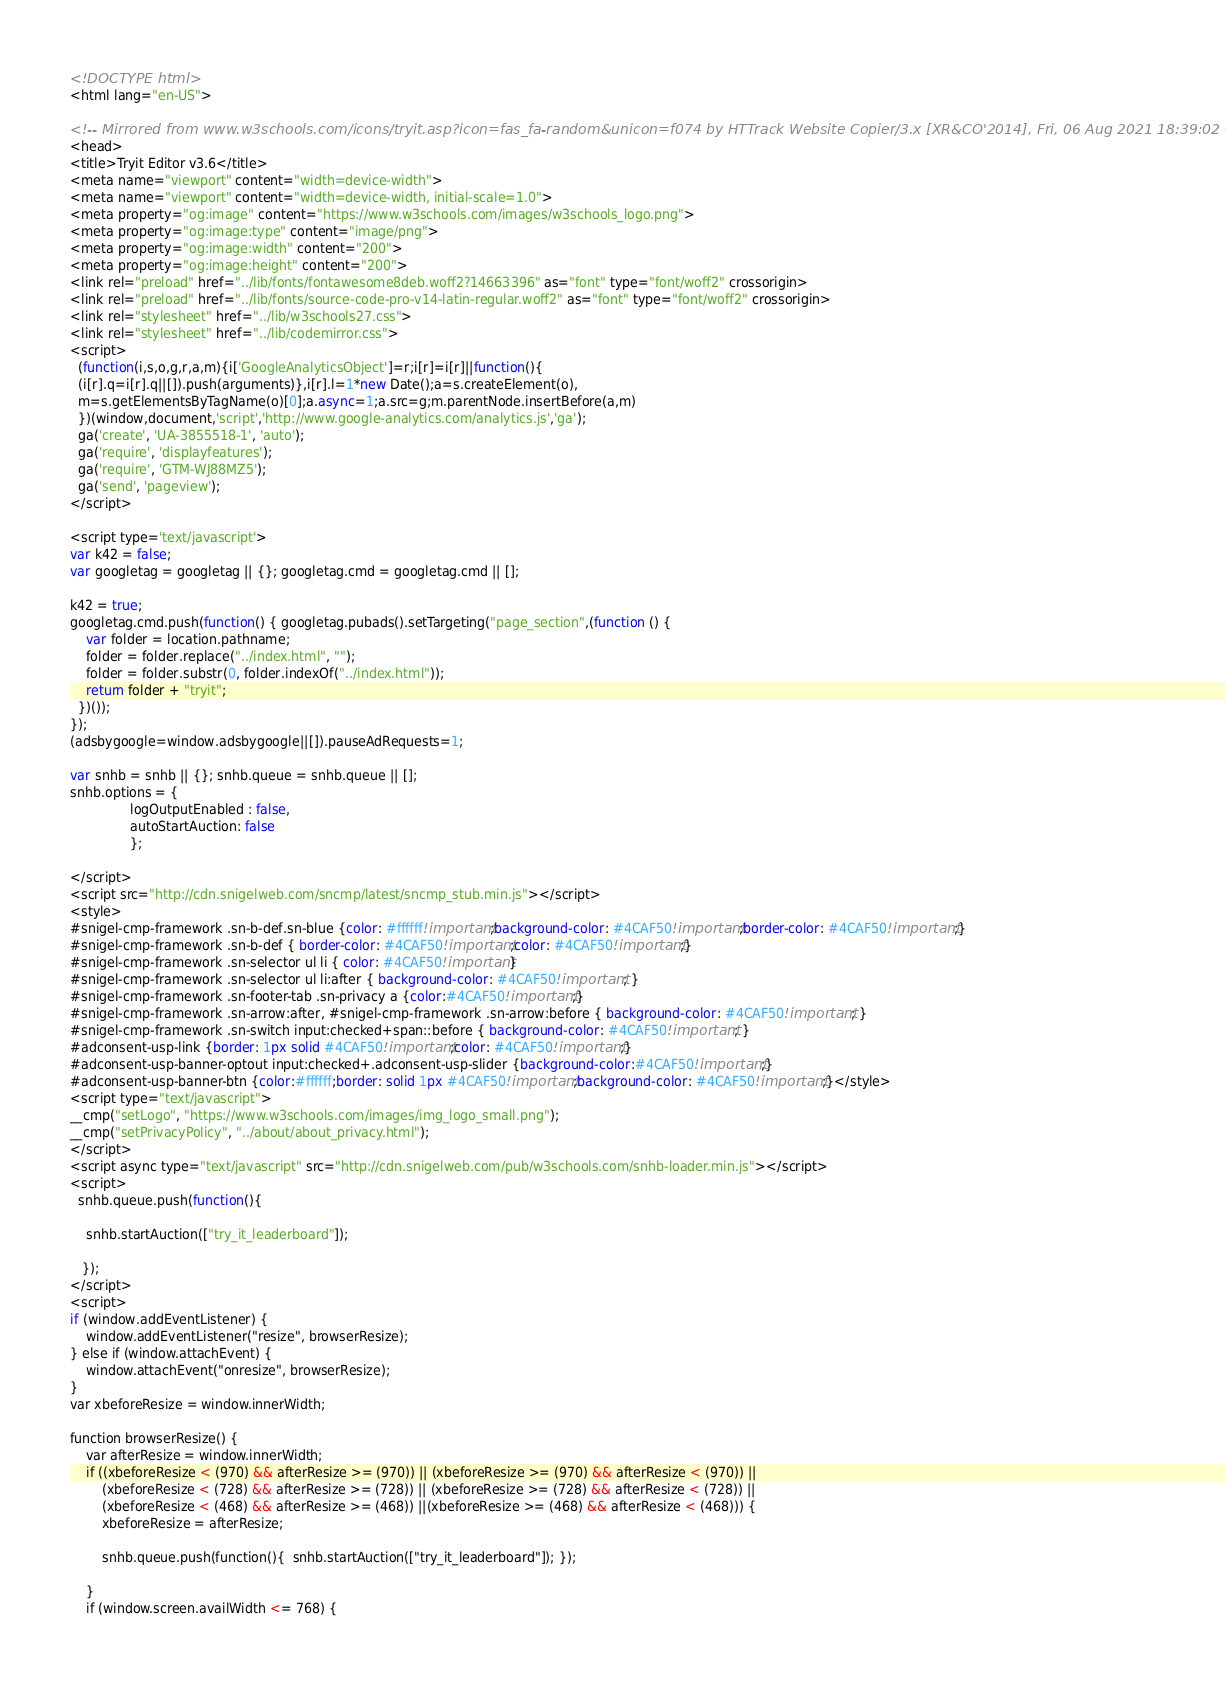<code> <loc_0><loc_0><loc_500><loc_500><_HTML_>
<!DOCTYPE html>
<html lang="en-US">

<!-- Mirrored from www.w3schools.com/icons/tryit.asp?icon=fas_fa-random&unicon=f074 by HTTrack Website Copier/3.x [XR&CO'2014], Fri, 06 Aug 2021 18:39:02 GMT -->
<head>
<title>Tryit Editor v3.6</title>
<meta name="viewport" content="width=device-width">
<meta name="viewport" content="width=device-width, initial-scale=1.0">
<meta property="og:image" content="https://www.w3schools.com/images/w3schools_logo.png">
<meta property="og:image:type" content="image/png">
<meta property="og:image:width" content="200">
<meta property="og:image:height" content="200">
<link rel="preload" href="../lib/fonts/fontawesome8deb.woff2?14663396" as="font" type="font/woff2" crossorigin> 
<link rel="preload" href="../lib/fonts/source-code-pro-v14-latin-regular.woff2" as="font" type="font/woff2" crossorigin> 
<link rel="stylesheet" href="../lib/w3schools27.css">
<link rel="stylesheet" href="../lib/codemirror.css">
<script>
  (function(i,s,o,g,r,a,m){i['GoogleAnalyticsObject']=r;i[r]=i[r]||function(){
  (i[r].q=i[r].q||[]).push(arguments)},i[r].l=1*new Date();a=s.createElement(o),
  m=s.getElementsByTagName(o)[0];a.async=1;a.src=g;m.parentNode.insertBefore(a,m)
  })(window,document,'script','http://www.google-analytics.com/analytics.js','ga');
  ga('create', 'UA-3855518-1', 'auto');
  ga('require', 'displayfeatures');
  ga('require', 'GTM-WJ88MZ5');
  ga('send', 'pageview');
</script>

<script type='text/javascript'>
var k42 = false;
var googletag = googletag || {}; googletag.cmd = googletag.cmd || [];

k42 = true;
googletag.cmd.push(function() { googletag.pubads().setTargeting("page_section",(function () {
    var folder = location.pathname;
    folder = folder.replace("../index.html", "");
    folder = folder.substr(0, folder.indexOf("../index.html"));
    return folder + "tryit";
  })());
});  
(adsbygoogle=window.adsbygoogle||[]).pauseAdRequests=1;

var snhb = snhb || {}; snhb.queue = snhb.queue || [];
snhb.options = {
               logOutputEnabled : false,
               autoStartAuction: false
               };

</script>
<script src="http://cdn.snigelweb.com/sncmp/latest/sncmp_stub.min.js"></script>
<style>
#snigel-cmp-framework .sn-b-def.sn-blue {color: #ffffff!important;background-color: #4CAF50!important;border-color: #4CAF50!important;}
#snigel-cmp-framework .sn-b-def { border-color: #4CAF50!important;color: #4CAF50!important;}
#snigel-cmp-framework .sn-selector ul li { color: #4CAF50!important}
#snigel-cmp-framework .sn-selector ul li:after { background-color: #4CAF50!important; }
#snigel-cmp-framework .sn-footer-tab .sn-privacy a {color:#4CAF50!important;}
#snigel-cmp-framework .sn-arrow:after, #snigel-cmp-framework .sn-arrow:before { background-color: #4CAF50!important; }
#snigel-cmp-framework .sn-switch input:checked+span::before { background-color: #4CAF50!important; }
#adconsent-usp-link {border: 1px solid #4CAF50!important;color: #4CAF50!important;}
#adconsent-usp-banner-optout input:checked+.adconsent-usp-slider {background-color:#4CAF50!important;}
#adconsent-usp-banner-btn {color:#ffffff;border: solid 1px #4CAF50!important;background-color: #4CAF50!important;}</style>
<script type="text/javascript">
__cmp("setLogo", "https://www.w3schools.com/images/img_logo_small.png");
__cmp("setPrivacyPolicy", "../about/about_privacy.html");
</script>
<script async type="text/javascript" src="http://cdn.snigelweb.com/pub/w3schools.com/snhb-loader.min.js"></script>
<script>
  snhb.queue.push(function(){

    snhb.startAuction(["try_it_leaderboard"]);

   });
</script>
<script>
if (window.addEventListener) {              
    window.addEventListener("resize", browserResize);
} else if (window.attachEvent) {                 
    window.attachEvent("onresize", browserResize);
}
var xbeforeResize = window.innerWidth;

function browserResize() {
    var afterResize = window.innerWidth;
    if ((xbeforeResize < (970) && afterResize >= (970)) || (xbeforeResize >= (970) && afterResize < (970)) ||
        (xbeforeResize < (728) && afterResize >= (728)) || (xbeforeResize >= (728) && afterResize < (728)) ||
        (xbeforeResize < (468) && afterResize >= (468)) ||(xbeforeResize >= (468) && afterResize < (468))) {
        xbeforeResize = afterResize;
        
        snhb.queue.push(function(){  snhb.startAuction(["try_it_leaderboard"]); });
         
    }
    if (window.screen.availWidth <= 768) {</code> 